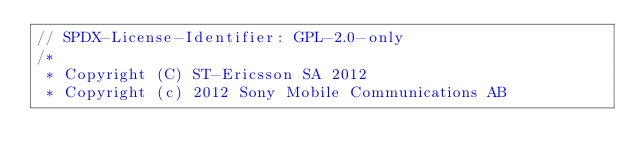Convert code to text. <code><loc_0><loc_0><loc_500><loc_500><_C_>// SPDX-License-Identifier: GPL-2.0-only
/*
 * Copyright (C) ST-Ericsson SA 2012
 * Copyright (c) 2012 Sony Mobile Communications AB</code> 